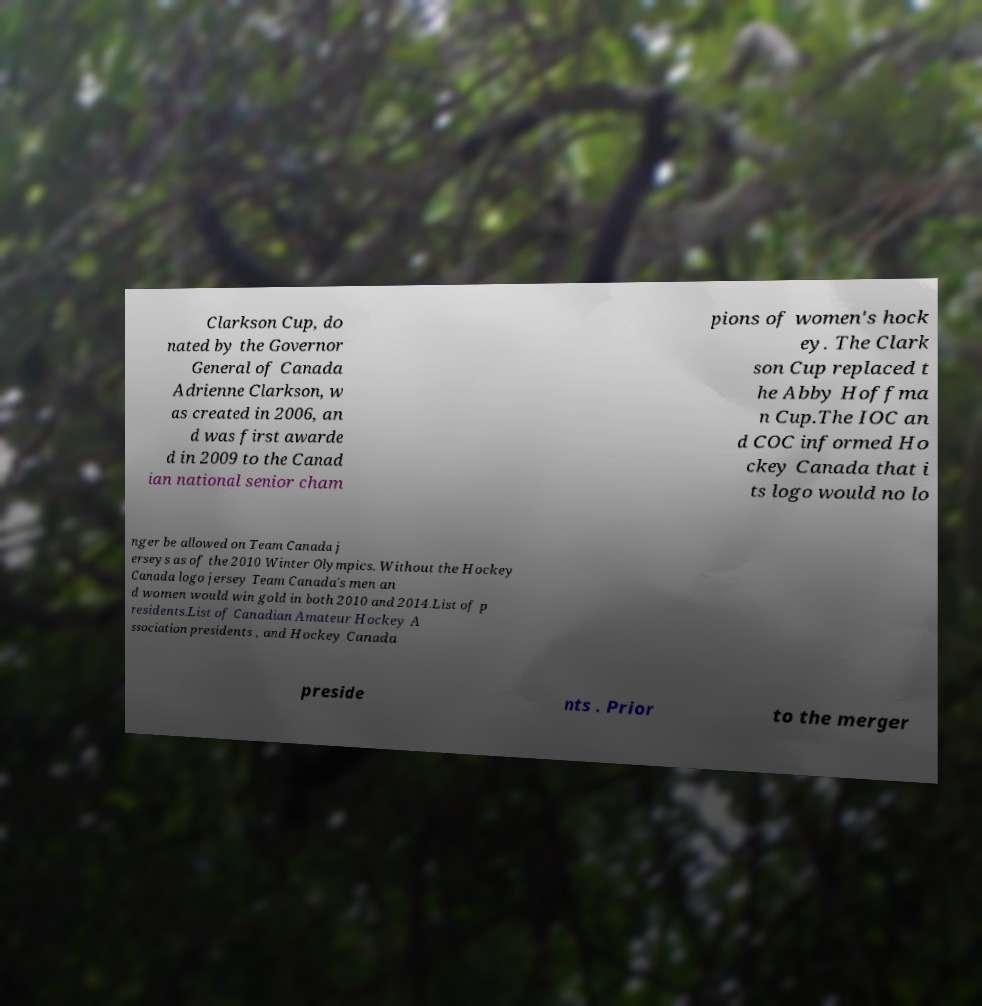I need the written content from this picture converted into text. Can you do that? Clarkson Cup, do nated by the Governor General of Canada Adrienne Clarkson, w as created in 2006, an d was first awarde d in 2009 to the Canad ian national senior cham pions of women's hock ey. The Clark son Cup replaced t he Abby Hoffma n Cup.The IOC an d COC informed Ho ckey Canada that i ts logo would no lo nger be allowed on Team Canada j erseys as of the 2010 Winter Olympics. Without the Hockey Canada logo jersey Team Canada's men an d women would win gold in both 2010 and 2014.List of p residents.List of Canadian Amateur Hockey A ssociation presidents , and Hockey Canada preside nts . Prior to the merger 